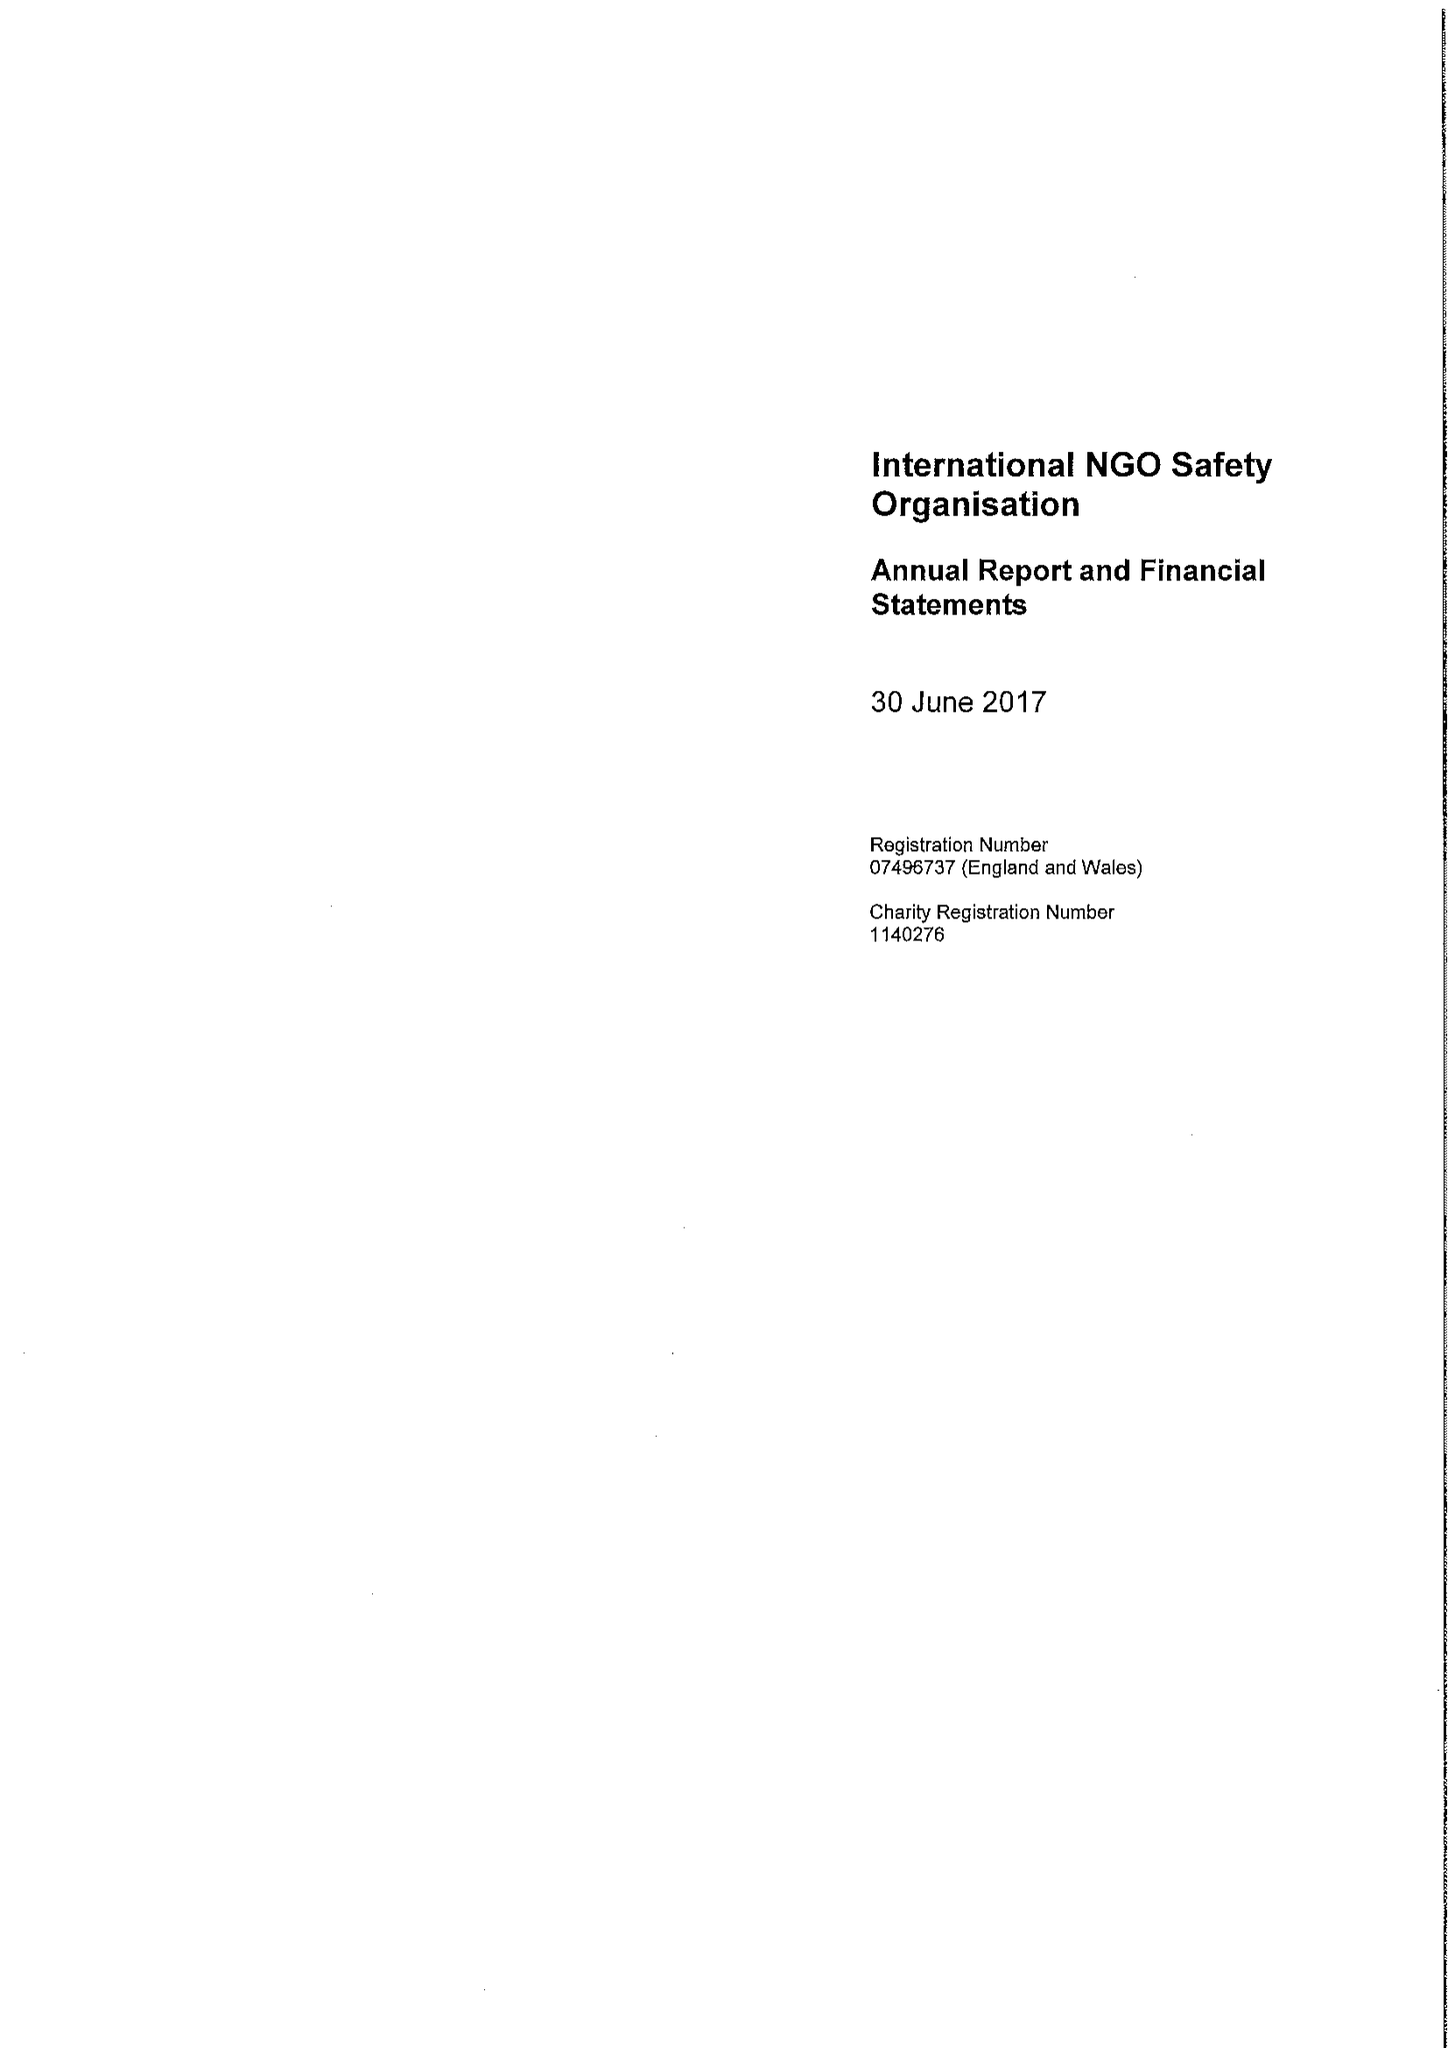What is the value for the address__postcode?
Answer the question using a single word or phrase. EC4R 1BE 